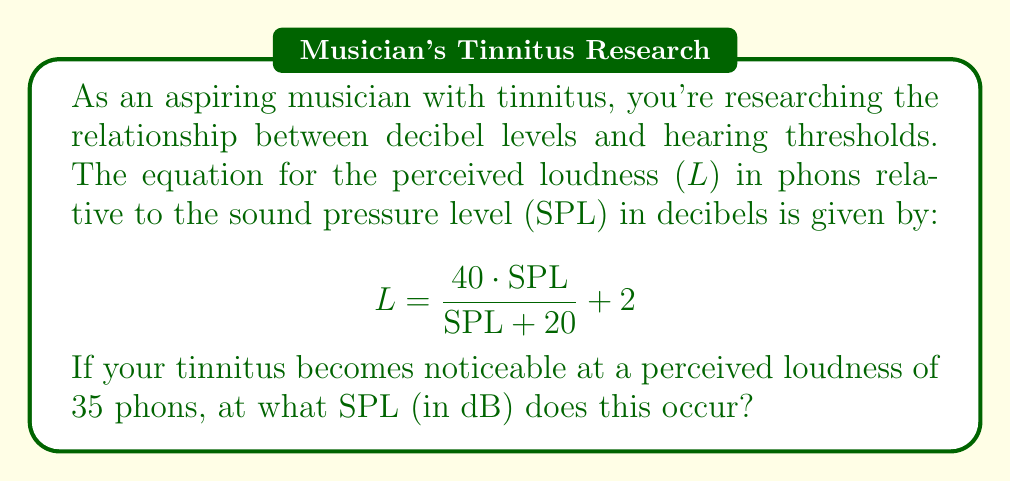Could you help me with this problem? Let's solve this step-by-step:

1) We start with the equation:
   $$L = \frac{40 \cdot SPL}{SPL + 20} + 2$$

2) We know that L = 35 phons, so we substitute this:
   $$35 = \frac{40 \cdot SPL}{SPL + 20} + 2$$

3) Subtract 2 from both sides:
   $$33 = \frac{40 \cdot SPL}{SPL + 20}$$

4) Multiply both sides by (SPL + 20):
   $$33(SPL + 20) = 40 \cdot SPL$$

5) Expand the left side:
   $$33 \cdot SPL + 660 = 40 \cdot SPL$$

6) Subtract 33 · SPL from both sides:
   $$660 = 7 \cdot SPL$$

7) Divide both sides by 7:
   $$\frac{660}{7} = SPL$$

8) Simplify:
   $$SPL = 94.29$$

Therefore, the tinnitus becomes noticeable at approximately 94.29 dB SPL.
Answer: 94.29 dB 